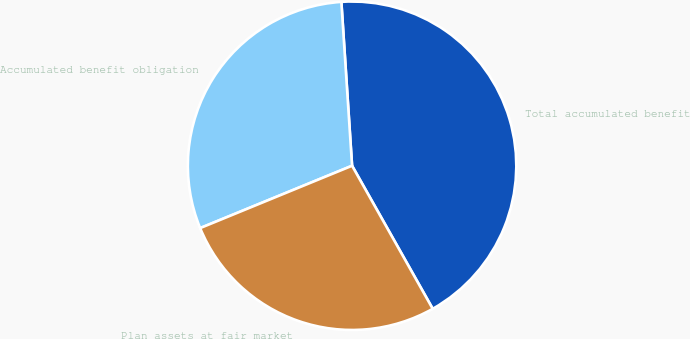Convert chart. <chart><loc_0><loc_0><loc_500><loc_500><pie_chart><fcel>Total accumulated benefit<fcel>Accumulated benefit obligation<fcel>Plan assets at fair market<nl><fcel>42.87%<fcel>30.16%<fcel>26.97%<nl></chart> 